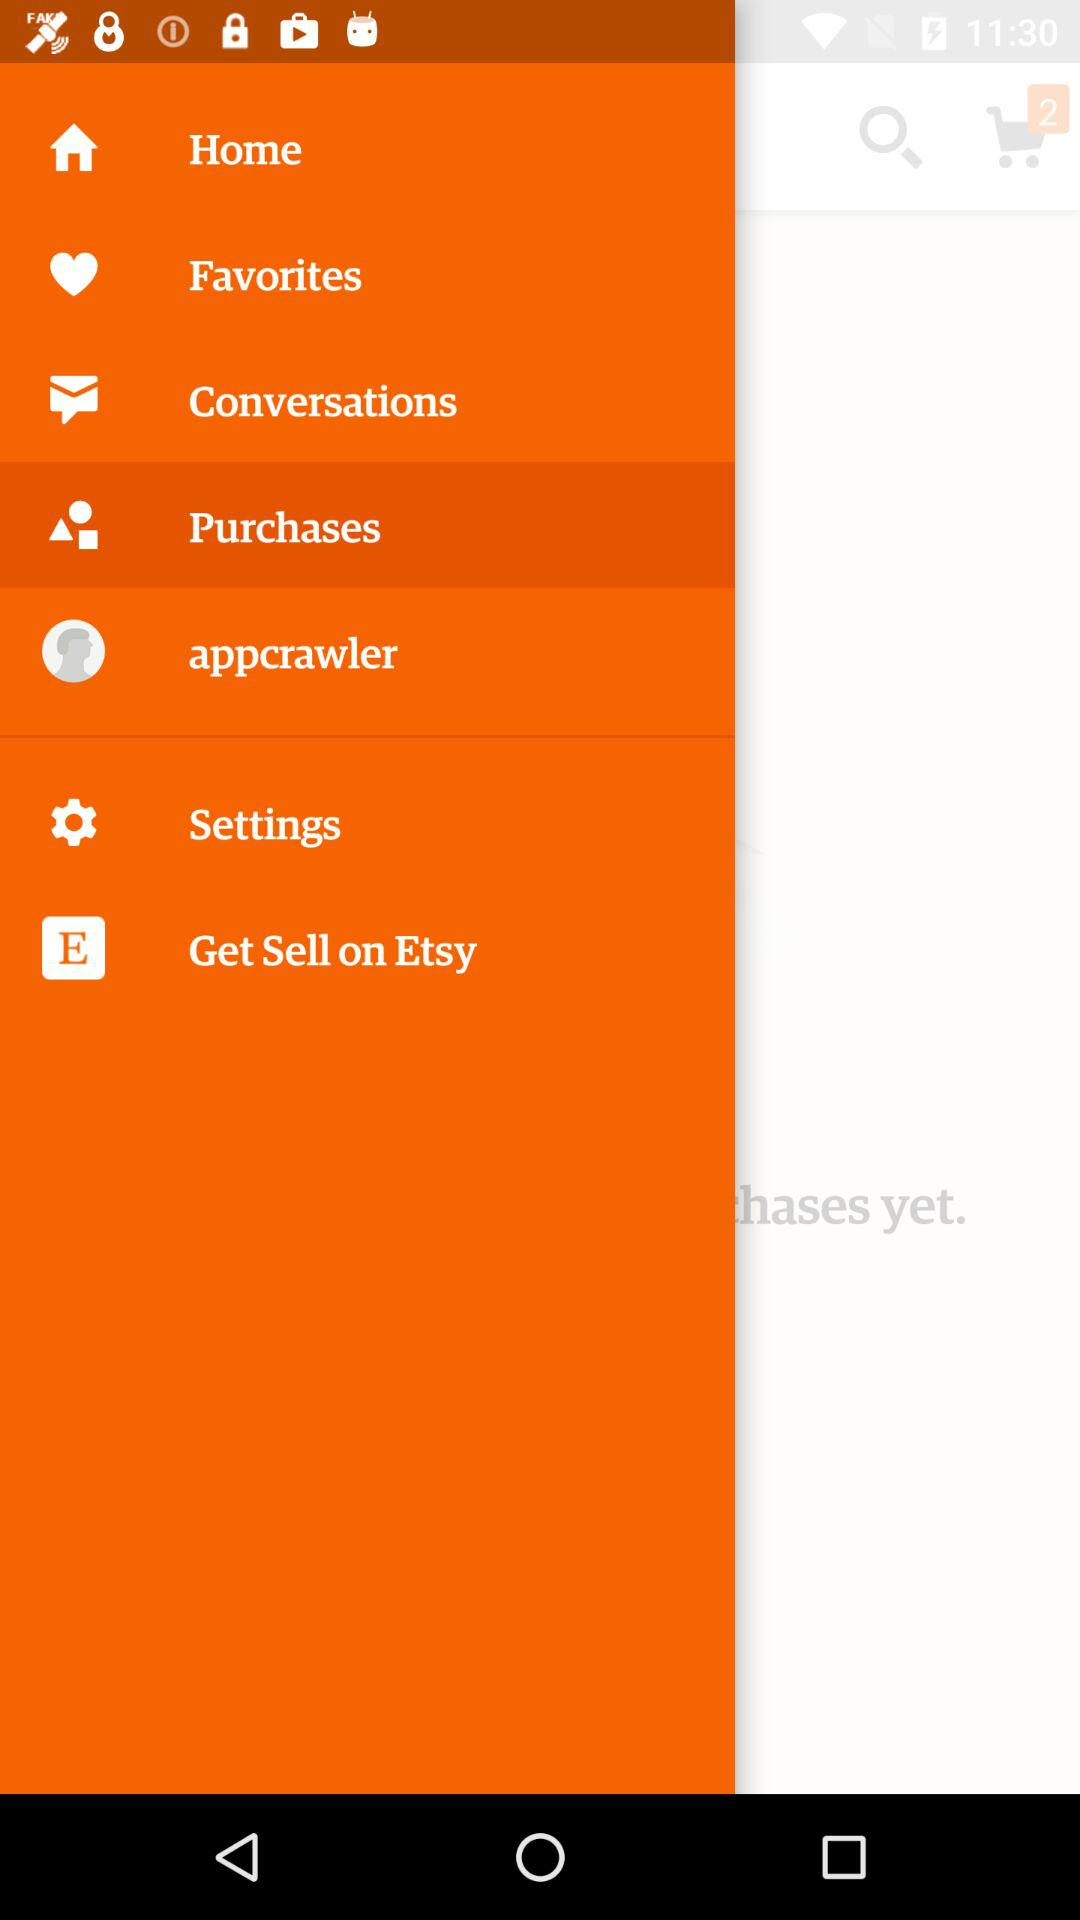Which item has been selected in the menu? The selected item is "Purchases". 